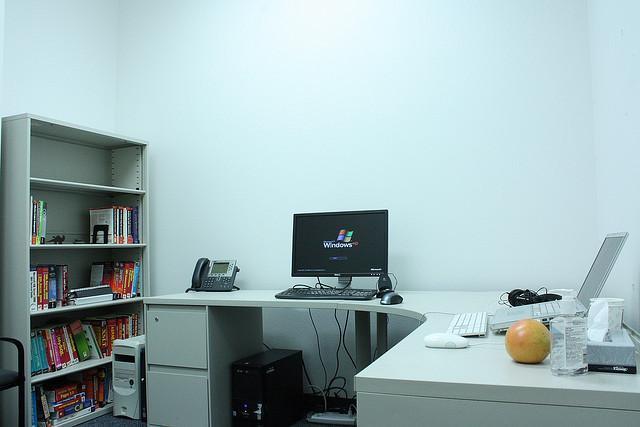What general subject do the books in the bookcase to the left of the phone cover?
Answer the question by selecting the correct answer among the 4 following choices and explain your choice with a short sentence. The answer should be formatted with the following format: `Answer: choice
Rationale: rationale.`
Options: Mathematics, engineering, history, information technology. Answer: information technology.
Rationale: The subject is it. 